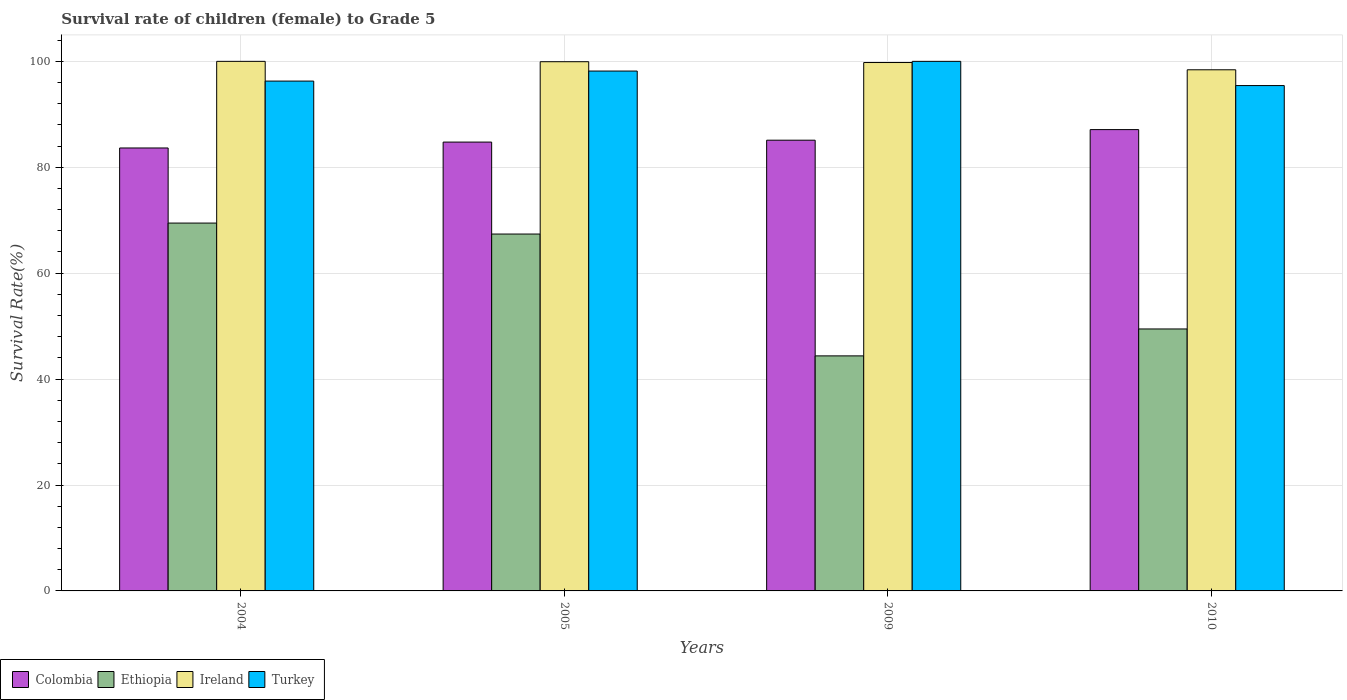How many groups of bars are there?
Your answer should be compact. 4. Are the number of bars per tick equal to the number of legend labels?
Ensure brevity in your answer.  Yes. Are the number of bars on each tick of the X-axis equal?
Provide a short and direct response. Yes. How many bars are there on the 3rd tick from the left?
Make the answer very short. 4. How many bars are there on the 3rd tick from the right?
Give a very brief answer. 4. What is the label of the 2nd group of bars from the left?
Your answer should be compact. 2005. In how many cases, is the number of bars for a given year not equal to the number of legend labels?
Make the answer very short. 0. What is the survival rate of female children to grade 5 in Ethiopia in 2009?
Offer a very short reply. 44.38. Across all years, what is the maximum survival rate of female children to grade 5 in Colombia?
Keep it short and to the point. 87.11. Across all years, what is the minimum survival rate of female children to grade 5 in Turkey?
Offer a very short reply. 95.43. In which year was the survival rate of female children to grade 5 in Ethiopia maximum?
Provide a short and direct response. 2004. What is the total survival rate of female children to grade 5 in Turkey in the graph?
Your answer should be compact. 389.87. What is the difference between the survival rate of female children to grade 5 in Colombia in 2004 and that in 2010?
Ensure brevity in your answer.  -3.47. What is the difference between the survival rate of female children to grade 5 in Colombia in 2005 and the survival rate of female children to grade 5 in Turkey in 2004?
Make the answer very short. -11.52. What is the average survival rate of female children to grade 5 in Turkey per year?
Offer a terse response. 97.47. In the year 2004, what is the difference between the survival rate of female children to grade 5 in Colombia and survival rate of female children to grade 5 in Ethiopia?
Offer a very short reply. 14.18. What is the ratio of the survival rate of female children to grade 5 in Colombia in 2009 to that in 2010?
Give a very brief answer. 0.98. What is the difference between the highest and the second highest survival rate of female children to grade 5 in Turkey?
Your answer should be very brief. 1.83. What is the difference between the highest and the lowest survival rate of female children to grade 5 in Ireland?
Make the answer very short. 1.59. Is it the case that in every year, the sum of the survival rate of female children to grade 5 in Ireland and survival rate of female children to grade 5 in Ethiopia is greater than the sum of survival rate of female children to grade 5 in Turkey and survival rate of female children to grade 5 in Colombia?
Keep it short and to the point. Yes. What does the 3rd bar from the left in 2009 represents?
Keep it short and to the point. Ireland. What does the 4th bar from the right in 2004 represents?
Give a very brief answer. Colombia. How many bars are there?
Your answer should be very brief. 16. How many years are there in the graph?
Offer a terse response. 4. What is the difference between two consecutive major ticks on the Y-axis?
Give a very brief answer. 20. Are the values on the major ticks of Y-axis written in scientific E-notation?
Your answer should be compact. No. Does the graph contain grids?
Provide a short and direct response. Yes. Where does the legend appear in the graph?
Your answer should be compact. Bottom left. What is the title of the graph?
Give a very brief answer. Survival rate of children (female) to Grade 5. Does "Madagascar" appear as one of the legend labels in the graph?
Provide a short and direct response. No. What is the label or title of the X-axis?
Keep it short and to the point. Years. What is the label or title of the Y-axis?
Offer a very short reply. Survival Rate(%). What is the Survival Rate(%) of Colombia in 2004?
Your response must be concise. 83.64. What is the Survival Rate(%) in Ethiopia in 2004?
Your answer should be very brief. 69.46. What is the Survival Rate(%) of Turkey in 2004?
Make the answer very short. 96.27. What is the Survival Rate(%) of Colombia in 2005?
Make the answer very short. 84.75. What is the Survival Rate(%) in Ethiopia in 2005?
Ensure brevity in your answer.  67.39. What is the Survival Rate(%) of Ireland in 2005?
Make the answer very short. 99.93. What is the Survival Rate(%) in Turkey in 2005?
Your response must be concise. 98.17. What is the Survival Rate(%) in Colombia in 2009?
Your response must be concise. 85.11. What is the Survival Rate(%) in Ethiopia in 2009?
Keep it short and to the point. 44.38. What is the Survival Rate(%) in Ireland in 2009?
Offer a very short reply. 99.78. What is the Survival Rate(%) in Colombia in 2010?
Your answer should be compact. 87.11. What is the Survival Rate(%) of Ethiopia in 2010?
Your answer should be compact. 49.47. What is the Survival Rate(%) in Ireland in 2010?
Your response must be concise. 98.41. What is the Survival Rate(%) of Turkey in 2010?
Your answer should be compact. 95.43. Across all years, what is the maximum Survival Rate(%) in Colombia?
Keep it short and to the point. 87.11. Across all years, what is the maximum Survival Rate(%) of Ethiopia?
Give a very brief answer. 69.46. Across all years, what is the maximum Survival Rate(%) of Ireland?
Make the answer very short. 100. Across all years, what is the maximum Survival Rate(%) in Turkey?
Ensure brevity in your answer.  100. Across all years, what is the minimum Survival Rate(%) in Colombia?
Provide a short and direct response. 83.64. Across all years, what is the minimum Survival Rate(%) in Ethiopia?
Provide a short and direct response. 44.38. Across all years, what is the minimum Survival Rate(%) of Ireland?
Offer a terse response. 98.41. Across all years, what is the minimum Survival Rate(%) in Turkey?
Keep it short and to the point. 95.43. What is the total Survival Rate(%) in Colombia in the graph?
Offer a very short reply. 340.62. What is the total Survival Rate(%) in Ethiopia in the graph?
Give a very brief answer. 230.7. What is the total Survival Rate(%) in Ireland in the graph?
Keep it short and to the point. 398.12. What is the total Survival Rate(%) of Turkey in the graph?
Make the answer very short. 389.87. What is the difference between the Survival Rate(%) of Colombia in 2004 and that in 2005?
Provide a short and direct response. -1.11. What is the difference between the Survival Rate(%) of Ethiopia in 2004 and that in 2005?
Keep it short and to the point. 2.07. What is the difference between the Survival Rate(%) of Ireland in 2004 and that in 2005?
Offer a very short reply. 0.07. What is the difference between the Survival Rate(%) in Turkey in 2004 and that in 2005?
Offer a very short reply. -1.89. What is the difference between the Survival Rate(%) of Colombia in 2004 and that in 2009?
Provide a short and direct response. -1.47. What is the difference between the Survival Rate(%) of Ethiopia in 2004 and that in 2009?
Ensure brevity in your answer.  25.08. What is the difference between the Survival Rate(%) in Ireland in 2004 and that in 2009?
Your answer should be very brief. 0.22. What is the difference between the Survival Rate(%) in Turkey in 2004 and that in 2009?
Keep it short and to the point. -3.73. What is the difference between the Survival Rate(%) of Colombia in 2004 and that in 2010?
Provide a succinct answer. -3.47. What is the difference between the Survival Rate(%) in Ethiopia in 2004 and that in 2010?
Your answer should be very brief. 19.99. What is the difference between the Survival Rate(%) in Ireland in 2004 and that in 2010?
Your answer should be compact. 1.59. What is the difference between the Survival Rate(%) in Turkey in 2004 and that in 2010?
Your response must be concise. 0.85. What is the difference between the Survival Rate(%) of Colombia in 2005 and that in 2009?
Provide a short and direct response. -0.36. What is the difference between the Survival Rate(%) in Ethiopia in 2005 and that in 2009?
Keep it short and to the point. 23.01. What is the difference between the Survival Rate(%) of Ireland in 2005 and that in 2009?
Offer a terse response. 0.15. What is the difference between the Survival Rate(%) of Turkey in 2005 and that in 2009?
Keep it short and to the point. -1.83. What is the difference between the Survival Rate(%) of Colombia in 2005 and that in 2010?
Your answer should be very brief. -2.36. What is the difference between the Survival Rate(%) in Ethiopia in 2005 and that in 2010?
Offer a terse response. 17.92. What is the difference between the Survival Rate(%) of Ireland in 2005 and that in 2010?
Offer a terse response. 1.52. What is the difference between the Survival Rate(%) of Turkey in 2005 and that in 2010?
Give a very brief answer. 2.74. What is the difference between the Survival Rate(%) in Colombia in 2009 and that in 2010?
Provide a succinct answer. -2. What is the difference between the Survival Rate(%) in Ethiopia in 2009 and that in 2010?
Your answer should be very brief. -5.08. What is the difference between the Survival Rate(%) of Ireland in 2009 and that in 2010?
Your response must be concise. 1.37. What is the difference between the Survival Rate(%) of Turkey in 2009 and that in 2010?
Offer a very short reply. 4.57. What is the difference between the Survival Rate(%) in Colombia in 2004 and the Survival Rate(%) in Ethiopia in 2005?
Keep it short and to the point. 16.25. What is the difference between the Survival Rate(%) in Colombia in 2004 and the Survival Rate(%) in Ireland in 2005?
Provide a succinct answer. -16.29. What is the difference between the Survival Rate(%) in Colombia in 2004 and the Survival Rate(%) in Turkey in 2005?
Ensure brevity in your answer.  -14.52. What is the difference between the Survival Rate(%) in Ethiopia in 2004 and the Survival Rate(%) in Ireland in 2005?
Ensure brevity in your answer.  -30.47. What is the difference between the Survival Rate(%) in Ethiopia in 2004 and the Survival Rate(%) in Turkey in 2005?
Provide a succinct answer. -28.71. What is the difference between the Survival Rate(%) of Ireland in 2004 and the Survival Rate(%) of Turkey in 2005?
Offer a very short reply. 1.83. What is the difference between the Survival Rate(%) in Colombia in 2004 and the Survival Rate(%) in Ethiopia in 2009?
Provide a short and direct response. 39.26. What is the difference between the Survival Rate(%) in Colombia in 2004 and the Survival Rate(%) in Ireland in 2009?
Make the answer very short. -16.13. What is the difference between the Survival Rate(%) of Colombia in 2004 and the Survival Rate(%) of Turkey in 2009?
Provide a short and direct response. -16.36. What is the difference between the Survival Rate(%) of Ethiopia in 2004 and the Survival Rate(%) of Ireland in 2009?
Give a very brief answer. -30.32. What is the difference between the Survival Rate(%) of Ethiopia in 2004 and the Survival Rate(%) of Turkey in 2009?
Ensure brevity in your answer.  -30.54. What is the difference between the Survival Rate(%) in Ireland in 2004 and the Survival Rate(%) in Turkey in 2009?
Ensure brevity in your answer.  0. What is the difference between the Survival Rate(%) of Colombia in 2004 and the Survival Rate(%) of Ethiopia in 2010?
Your answer should be very brief. 34.18. What is the difference between the Survival Rate(%) of Colombia in 2004 and the Survival Rate(%) of Ireland in 2010?
Give a very brief answer. -14.76. What is the difference between the Survival Rate(%) of Colombia in 2004 and the Survival Rate(%) of Turkey in 2010?
Make the answer very short. -11.78. What is the difference between the Survival Rate(%) of Ethiopia in 2004 and the Survival Rate(%) of Ireland in 2010?
Provide a short and direct response. -28.95. What is the difference between the Survival Rate(%) of Ethiopia in 2004 and the Survival Rate(%) of Turkey in 2010?
Your answer should be compact. -25.97. What is the difference between the Survival Rate(%) in Ireland in 2004 and the Survival Rate(%) in Turkey in 2010?
Make the answer very short. 4.57. What is the difference between the Survival Rate(%) in Colombia in 2005 and the Survival Rate(%) in Ethiopia in 2009?
Your answer should be very brief. 40.37. What is the difference between the Survival Rate(%) in Colombia in 2005 and the Survival Rate(%) in Ireland in 2009?
Make the answer very short. -15.02. What is the difference between the Survival Rate(%) of Colombia in 2005 and the Survival Rate(%) of Turkey in 2009?
Make the answer very short. -15.24. What is the difference between the Survival Rate(%) of Ethiopia in 2005 and the Survival Rate(%) of Ireland in 2009?
Offer a terse response. -32.39. What is the difference between the Survival Rate(%) of Ethiopia in 2005 and the Survival Rate(%) of Turkey in 2009?
Provide a short and direct response. -32.61. What is the difference between the Survival Rate(%) in Ireland in 2005 and the Survival Rate(%) in Turkey in 2009?
Give a very brief answer. -0.07. What is the difference between the Survival Rate(%) of Colombia in 2005 and the Survival Rate(%) of Ethiopia in 2010?
Your answer should be very brief. 35.29. What is the difference between the Survival Rate(%) of Colombia in 2005 and the Survival Rate(%) of Ireland in 2010?
Make the answer very short. -13.65. What is the difference between the Survival Rate(%) of Colombia in 2005 and the Survival Rate(%) of Turkey in 2010?
Ensure brevity in your answer.  -10.67. What is the difference between the Survival Rate(%) in Ethiopia in 2005 and the Survival Rate(%) in Ireland in 2010?
Your response must be concise. -31.02. What is the difference between the Survival Rate(%) in Ethiopia in 2005 and the Survival Rate(%) in Turkey in 2010?
Provide a short and direct response. -28.04. What is the difference between the Survival Rate(%) in Ireland in 2005 and the Survival Rate(%) in Turkey in 2010?
Provide a succinct answer. 4.5. What is the difference between the Survival Rate(%) of Colombia in 2009 and the Survival Rate(%) of Ethiopia in 2010?
Your response must be concise. 35.64. What is the difference between the Survival Rate(%) in Colombia in 2009 and the Survival Rate(%) in Ireland in 2010?
Give a very brief answer. -13.3. What is the difference between the Survival Rate(%) in Colombia in 2009 and the Survival Rate(%) in Turkey in 2010?
Give a very brief answer. -10.32. What is the difference between the Survival Rate(%) in Ethiopia in 2009 and the Survival Rate(%) in Ireland in 2010?
Your answer should be very brief. -54.02. What is the difference between the Survival Rate(%) in Ethiopia in 2009 and the Survival Rate(%) in Turkey in 2010?
Your answer should be compact. -51.04. What is the difference between the Survival Rate(%) of Ireland in 2009 and the Survival Rate(%) of Turkey in 2010?
Your answer should be compact. 4.35. What is the average Survival Rate(%) in Colombia per year?
Keep it short and to the point. 85.16. What is the average Survival Rate(%) of Ethiopia per year?
Make the answer very short. 57.68. What is the average Survival Rate(%) in Ireland per year?
Your answer should be compact. 99.53. What is the average Survival Rate(%) in Turkey per year?
Your answer should be very brief. 97.47. In the year 2004, what is the difference between the Survival Rate(%) in Colombia and Survival Rate(%) in Ethiopia?
Provide a succinct answer. 14.18. In the year 2004, what is the difference between the Survival Rate(%) of Colombia and Survival Rate(%) of Ireland?
Provide a succinct answer. -16.36. In the year 2004, what is the difference between the Survival Rate(%) in Colombia and Survival Rate(%) in Turkey?
Ensure brevity in your answer.  -12.63. In the year 2004, what is the difference between the Survival Rate(%) in Ethiopia and Survival Rate(%) in Ireland?
Your answer should be very brief. -30.54. In the year 2004, what is the difference between the Survival Rate(%) of Ethiopia and Survival Rate(%) of Turkey?
Keep it short and to the point. -26.81. In the year 2004, what is the difference between the Survival Rate(%) in Ireland and Survival Rate(%) in Turkey?
Give a very brief answer. 3.73. In the year 2005, what is the difference between the Survival Rate(%) of Colombia and Survival Rate(%) of Ethiopia?
Your answer should be very brief. 17.36. In the year 2005, what is the difference between the Survival Rate(%) in Colombia and Survival Rate(%) in Ireland?
Ensure brevity in your answer.  -15.18. In the year 2005, what is the difference between the Survival Rate(%) in Colombia and Survival Rate(%) in Turkey?
Provide a succinct answer. -13.41. In the year 2005, what is the difference between the Survival Rate(%) in Ethiopia and Survival Rate(%) in Ireland?
Provide a short and direct response. -32.54. In the year 2005, what is the difference between the Survival Rate(%) in Ethiopia and Survival Rate(%) in Turkey?
Provide a short and direct response. -30.78. In the year 2005, what is the difference between the Survival Rate(%) in Ireland and Survival Rate(%) in Turkey?
Ensure brevity in your answer.  1.76. In the year 2009, what is the difference between the Survival Rate(%) in Colombia and Survival Rate(%) in Ethiopia?
Offer a very short reply. 40.73. In the year 2009, what is the difference between the Survival Rate(%) of Colombia and Survival Rate(%) of Ireland?
Make the answer very short. -14.67. In the year 2009, what is the difference between the Survival Rate(%) of Colombia and Survival Rate(%) of Turkey?
Your answer should be very brief. -14.89. In the year 2009, what is the difference between the Survival Rate(%) of Ethiopia and Survival Rate(%) of Ireland?
Give a very brief answer. -55.39. In the year 2009, what is the difference between the Survival Rate(%) in Ethiopia and Survival Rate(%) in Turkey?
Make the answer very short. -55.62. In the year 2009, what is the difference between the Survival Rate(%) in Ireland and Survival Rate(%) in Turkey?
Your answer should be compact. -0.22. In the year 2010, what is the difference between the Survival Rate(%) in Colombia and Survival Rate(%) in Ethiopia?
Your answer should be compact. 37.65. In the year 2010, what is the difference between the Survival Rate(%) of Colombia and Survival Rate(%) of Ireland?
Make the answer very short. -11.29. In the year 2010, what is the difference between the Survival Rate(%) in Colombia and Survival Rate(%) in Turkey?
Give a very brief answer. -8.32. In the year 2010, what is the difference between the Survival Rate(%) of Ethiopia and Survival Rate(%) of Ireland?
Keep it short and to the point. -48.94. In the year 2010, what is the difference between the Survival Rate(%) in Ethiopia and Survival Rate(%) in Turkey?
Keep it short and to the point. -45.96. In the year 2010, what is the difference between the Survival Rate(%) in Ireland and Survival Rate(%) in Turkey?
Give a very brief answer. 2.98. What is the ratio of the Survival Rate(%) of Colombia in 2004 to that in 2005?
Make the answer very short. 0.99. What is the ratio of the Survival Rate(%) in Ethiopia in 2004 to that in 2005?
Provide a succinct answer. 1.03. What is the ratio of the Survival Rate(%) of Turkey in 2004 to that in 2005?
Keep it short and to the point. 0.98. What is the ratio of the Survival Rate(%) in Colombia in 2004 to that in 2009?
Offer a terse response. 0.98. What is the ratio of the Survival Rate(%) of Ethiopia in 2004 to that in 2009?
Offer a terse response. 1.57. What is the ratio of the Survival Rate(%) in Turkey in 2004 to that in 2009?
Your response must be concise. 0.96. What is the ratio of the Survival Rate(%) in Colombia in 2004 to that in 2010?
Your response must be concise. 0.96. What is the ratio of the Survival Rate(%) of Ethiopia in 2004 to that in 2010?
Provide a short and direct response. 1.4. What is the ratio of the Survival Rate(%) of Ireland in 2004 to that in 2010?
Provide a succinct answer. 1.02. What is the ratio of the Survival Rate(%) of Turkey in 2004 to that in 2010?
Ensure brevity in your answer.  1.01. What is the ratio of the Survival Rate(%) in Colombia in 2005 to that in 2009?
Ensure brevity in your answer.  1. What is the ratio of the Survival Rate(%) of Ethiopia in 2005 to that in 2009?
Give a very brief answer. 1.52. What is the ratio of the Survival Rate(%) in Turkey in 2005 to that in 2009?
Ensure brevity in your answer.  0.98. What is the ratio of the Survival Rate(%) of Colombia in 2005 to that in 2010?
Keep it short and to the point. 0.97. What is the ratio of the Survival Rate(%) of Ethiopia in 2005 to that in 2010?
Your answer should be very brief. 1.36. What is the ratio of the Survival Rate(%) in Ireland in 2005 to that in 2010?
Ensure brevity in your answer.  1.02. What is the ratio of the Survival Rate(%) in Turkey in 2005 to that in 2010?
Make the answer very short. 1.03. What is the ratio of the Survival Rate(%) of Colombia in 2009 to that in 2010?
Offer a terse response. 0.98. What is the ratio of the Survival Rate(%) in Ethiopia in 2009 to that in 2010?
Offer a very short reply. 0.9. What is the ratio of the Survival Rate(%) of Ireland in 2009 to that in 2010?
Make the answer very short. 1.01. What is the ratio of the Survival Rate(%) of Turkey in 2009 to that in 2010?
Make the answer very short. 1.05. What is the difference between the highest and the second highest Survival Rate(%) of Colombia?
Make the answer very short. 2. What is the difference between the highest and the second highest Survival Rate(%) of Ethiopia?
Provide a succinct answer. 2.07. What is the difference between the highest and the second highest Survival Rate(%) of Ireland?
Make the answer very short. 0.07. What is the difference between the highest and the second highest Survival Rate(%) of Turkey?
Provide a succinct answer. 1.83. What is the difference between the highest and the lowest Survival Rate(%) of Colombia?
Your response must be concise. 3.47. What is the difference between the highest and the lowest Survival Rate(%) in Ethiopia?
Provide a succinct answer. 25.08. What is the difference between the highest and the lowest Survival Rate(%) in Ireland?
Give a very brief answer. 1.59. What is the difference between the highest and the lowest Survival Rate(%) of Turkey?
Keep it short and to the point. 4.57. 